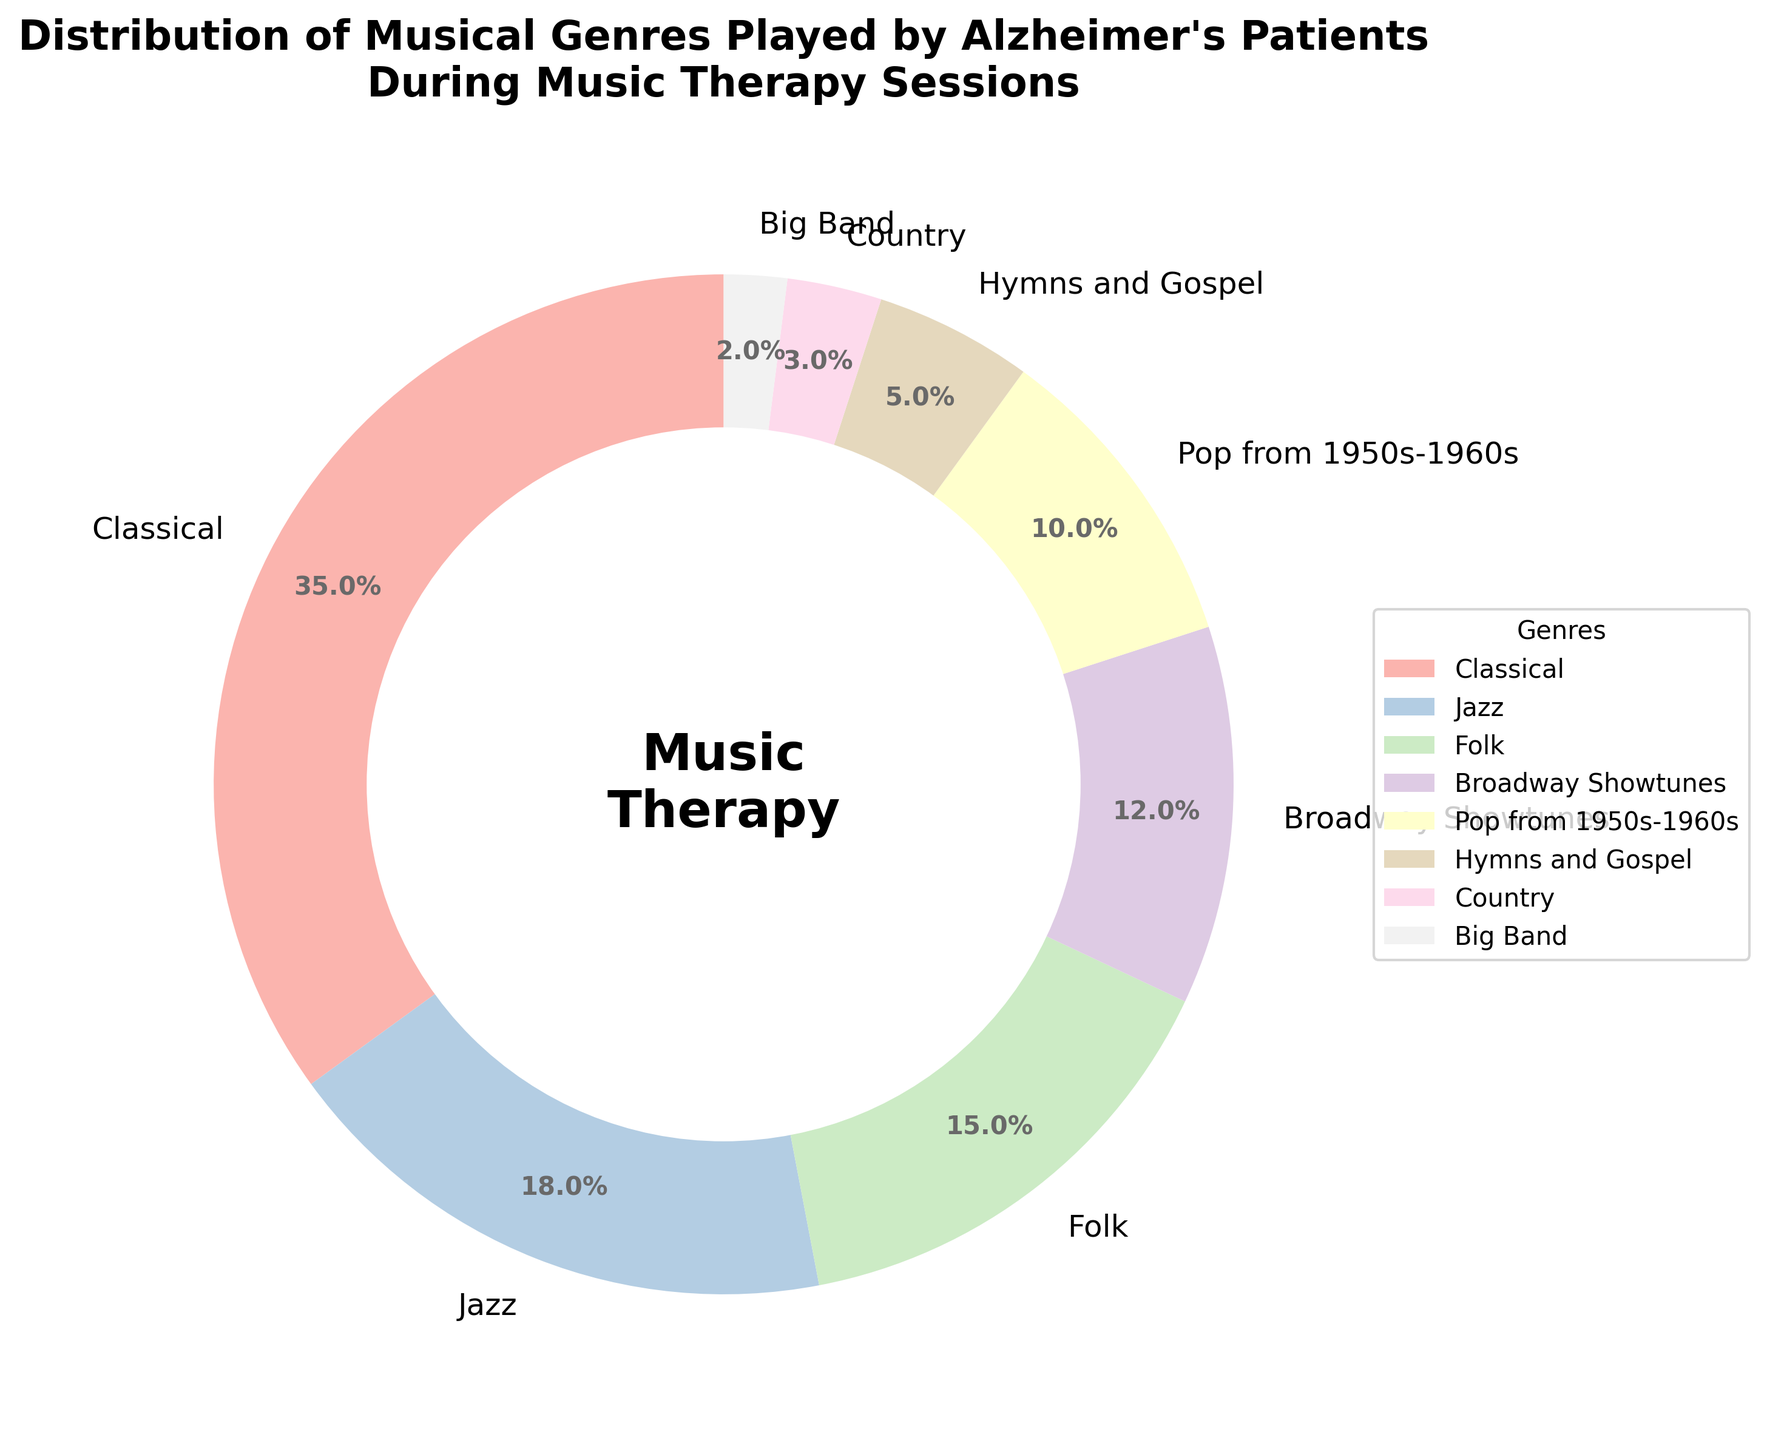Which genre is the most commonly played by Alzheimer's patients during music therapy sessions? Based on the pie chart, the genre with the highest percentage is easily identified. Classical music has the largest portion of the pie.
Answer: Classical What percentage of genres combined are related to popular or contemporary music (Pop from 1950s-1960s and Broadway Showtunes)? According to the pie chart, Pop from the 1950s-1960s accounts for 10% and Broadway Showtunes for 12%. Adding these together gives us 10% + 12%.
Answer: 22% How does the percentage of Jazz compare to the percentage of Hymns and Gospel? From the chart, Jazz has a percentage of 18% and Hymns and Gospel have 5%. Jazz has a greater percentage than Hymns and Gospel.
Answer: Greater Which genre has half the percentage share of the Classical genre? The Classical genre makes up 35%, half of which is 35% / 2 = 17.5%. The closest genre to this value would be Jazz, which is 18%.
Answer: Jazz What is the total percentage of all genres making up less than 10% each? Looking at the chart, the genres with less than 10% are Hymns and Gospel (5%), Country (3%), and Big Band (2%). Adding these up results in 5% + 3% + 2%.
Answer: 10% How much more popular is the most played genre compared to the least played genre? The most played genre is Classical at 35% and the least played genre is Big Band at 2%. Subtracting these gives 35% - 2%.
Answer: 33% What percentage of the genres are categorized as instrumental (Classical, Jazz, Big Band)? From the chart, Classical is 35%, Jazz is 18%, and Big Band is 2%. Adding these percentages together yields 35% + 18% + 2%.
Answer: 55% Compare the combined percentages of Jazz and Folk to that of Classical. Which is higher and by how much? Jazz is 18% and Folk is 15%, so combined they are 18% + 15% = 33%. Classical alone is 35%. Therefore, Classical is higher by 35% - 33%.
Answer: Classical by 2% Which genre's segment in the pie chart appears the smallest in size? The segments are proportional to their percentages. The smallest segment corresponds to the genre with the smallest percentage. In this case, it is Big Band with 2%.
Answer: Big Band 